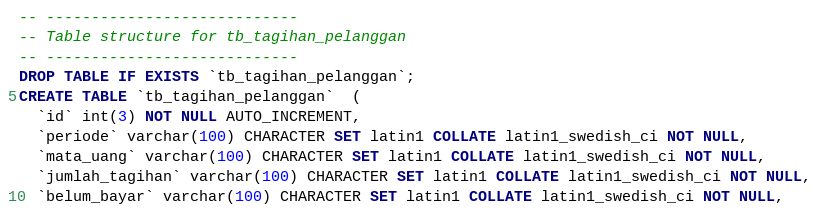<code> <loc_0><loc_0><loc_500><loc_500><_SQL_>
-- ----------------------------
-- Table structure for tb_tagihan_pelanggan
-- ----------------------------
DROP TABLE IF EXISTS `tb_tagihan_pelanggan`;
CREATE TABLE `tb_tagihan_pelanggan`  (
  `id` int(3) NOT NULL AUTO_INCREMENT,
  `periode` varchar(100) CHARACTER SET latin1 COLLATE latin1_swedish_ci NOT NULL,
  `mata_uang` varchar(100) CHARACTER SET latin1 COLLATE latin1_swedish_ci NOT NULL,
  `jumlah_tagihan` varchar(100) CHARACTER SET latin1 COLLATE latin1_swedish_ci NOT NULL,
  `belum_bayar` varchar(100) CHARACTER SET latin1 COLLATE latin1_swedish_ci NOT NULL,</code> 